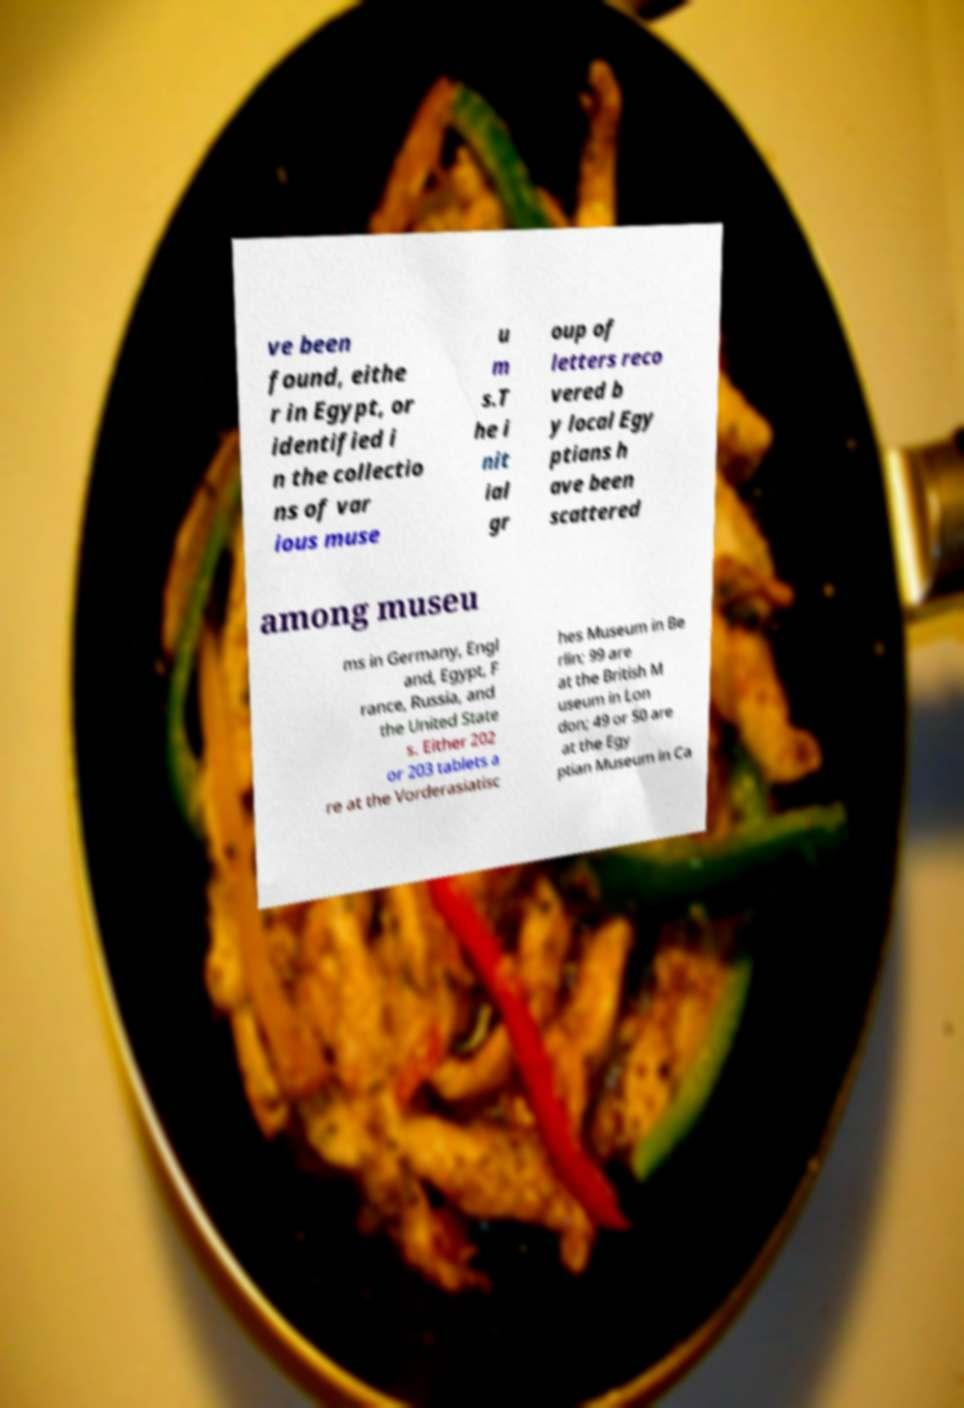For documentation purposes, I need the text within this image transcribed. Could you provide that? ve been found, eithe r in Egypt, or identified i n the collectio ns of var ious muse u m s.T he i nit ial gr oup of letters reco vered b y local Egy ptians h ave been scattered among museu ms in Germany, Engl and, Egypt, F rance, Russia, and the United State s. Either 202 or 203 tablets a re at the Vorderasiatisc hes Museum in Be rlin; 99 are at the British M useum in Lon don; 49 or 50 are at the Egy ptian Museum in Ca 